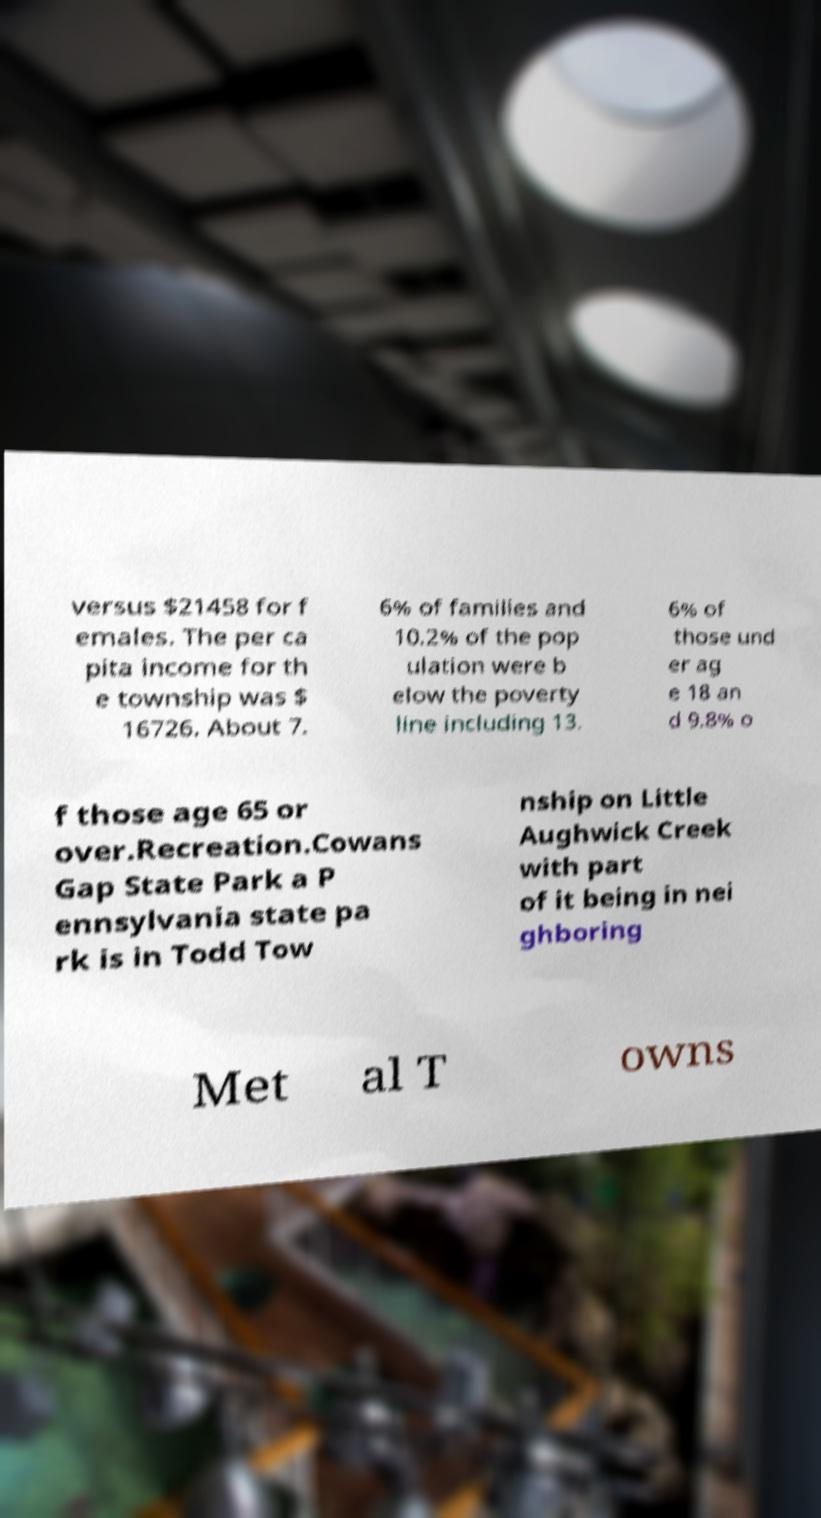Please identify and transcribe the text found in this image. versus $21458 for f emales. The per ca pita income for th e township was $ 16726. About 7. 6% of families and 10.2% of the pop ulation were b elow the poverty line including 13. 6% of those und er ag e 18 an d 9.8% o f those age 65 or over.Recreation.Cowans Gap State Park a P ennsylvania state pa rk is in Todd Tow nship on Little Aughwick Creek with part of it being in nei ghboring Met al T owns 